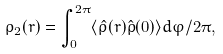Convert formula to latex. <formula><loc_0><loc_0><loc_500><loc_500>\rho _ { 2 } ( r ) = \int _ { 0 } ^ { 2 \pi } \langle \hat { \rho } ( { r } ) \hat { \rho } ( 0 ) \rangle d \varphi / 2 \pi ,</formula> 